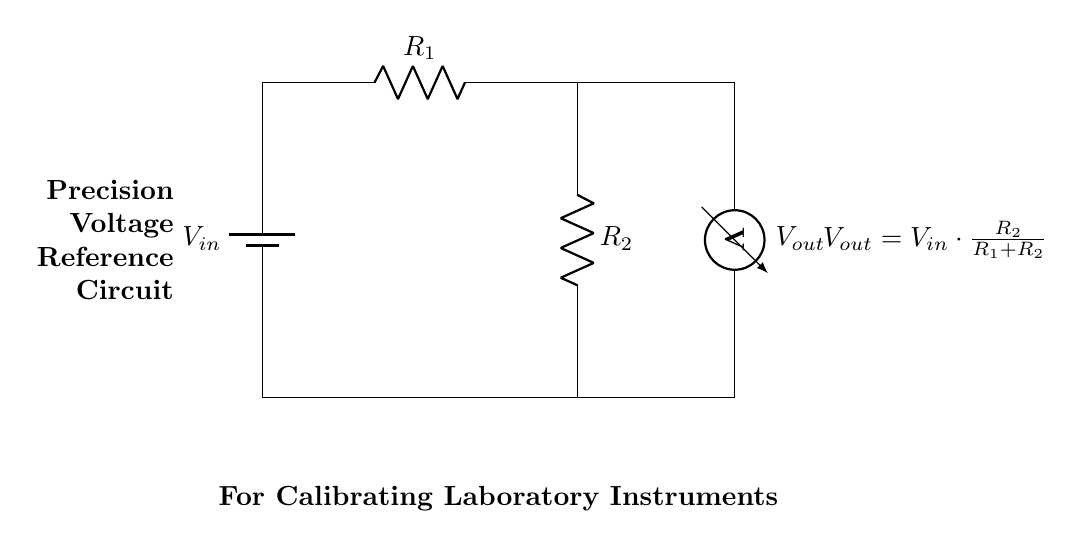What is the input voltage in this circuit? The input voltage is represented as \( V_{in} \) in the circuit diagram. It is the voltage supplied to the voltage divider.
Answer: \( V_{in} \) What components are used in this precision voltage reference circuit? The components in this circuit include a battery (for \( V_{in} \)), two resistors \( R_1 \) and \( R_2 \), and a voltmeter measuring \( V_{out} \).
Answer: Battery, \( R_1 \), \( R_2 \), Voltmeter What is the formula for \( V_{out} \) in this circuit? The circuit diagram includes a formula that states \( V_{out} = V_{in} \cdot \frac{R_2}{R_1 + R_2} \), showing the relationship between the resistors and input voltage.
Answer: \( V_{out} = V_{in} \cdot \frac{R_2}{R_1 + R_2} \) If \( R_1 \) is increased, what happens to \( V_{out} \)? Increasing \( R_1 \) increases the denominator of the fraction in the voltage divider formula, which results in a smaller \( V_{out} \), demonstrating the inverse relationship between \( R_1 \) and \( V_{out} \).
Answer: Decreases What is the role of the voltmeter in this circuit? The voltmeter measures the output voltage \( V_{out} \), providing a direct reading of the voltage across \( R_2 \) in this configuration, which is crucial for calibration purposes.
Answer: Measure \( V_{out} \) What is a common application of this voltage reference circuit? This circuit is typically used for calibrating laboratory instruments, as it produces a stable and precise voltage output necessary for accurate measurements.
Answer: Calibrating laboratory instruments 